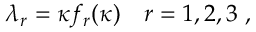Convert formula to latex. <formula><loc_0><loc_0><loc_500><loc_500>\lambda _ { r } = \kappa f _ { r } ( \kappa ) \quad r = 1 , 2 , 3 \, ,</formula> 